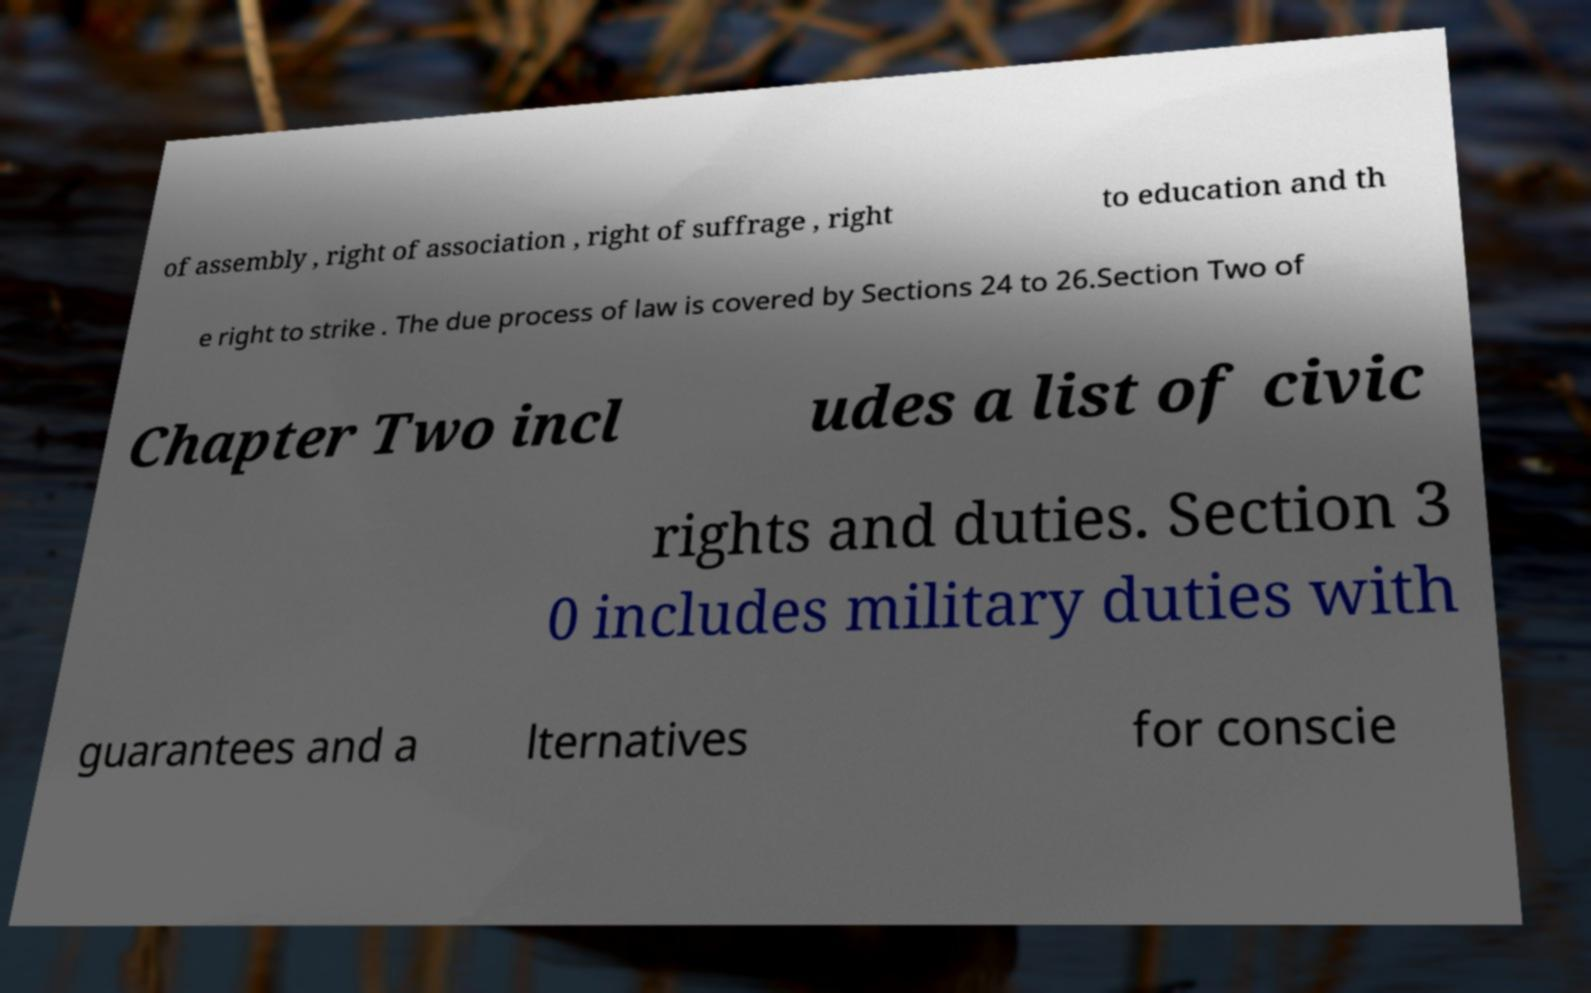I need the written content from this picture converted into text. Can you do that? of assembly , right of association , right of suffrage , right to education and th e right to strike . The due process of law is covered by Sections 24 to 26.Section Two of Chapter Two incl udes a list of civic rights and duties. Section 3 0 includes military duties with guarantees and a lternatives for conscie 